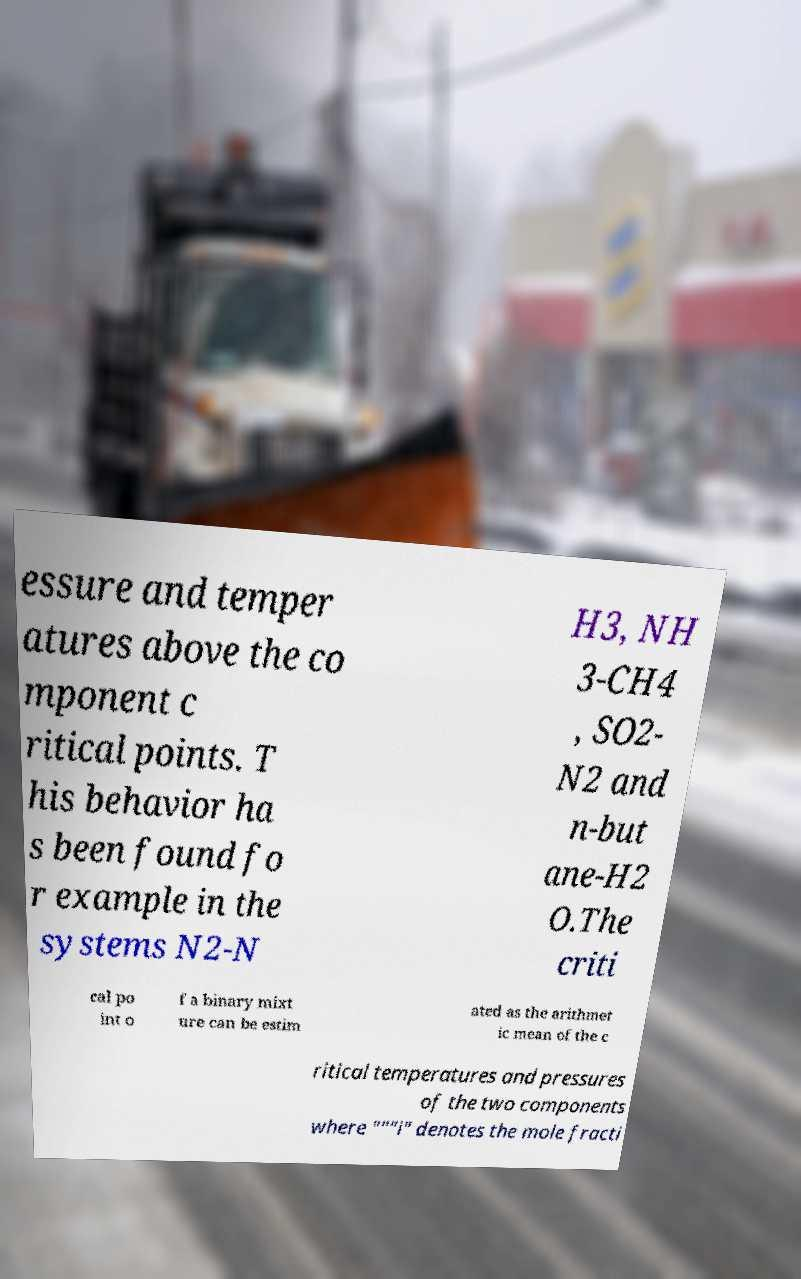For documentation purposes, I need the text within this image transcribed. Could you provide that? essure and temper atures above the co mponent c ritical points. T his behavior ha s been found fo r example in the systems N2-N H3, NH 3-CH4 , SO2- N2 and n-but ane-H2 O.The criti cal po int o f a binary mixt ure can be estim ated as the arithmet ic mean of the c ritical temperatures and pressures of the two components where """i" denotes the mole fracti 